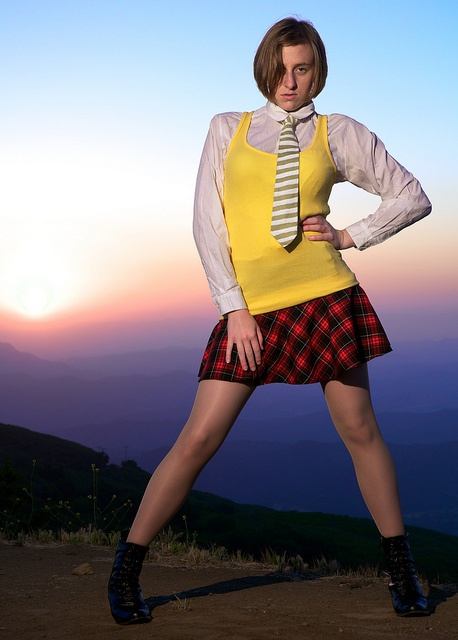Describe the objects in this image and their specific colors. I can see people in lightblue, black, maroon, brown, and darkgray tones and tie in lightblue, lightgray, tan, and olive tones in this image. 